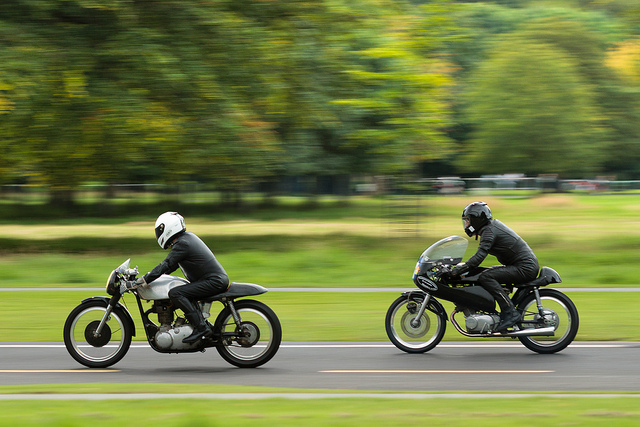Can you tell me more about the motorcycles they're riding? The motorcycles are styled after vintage or cafe racer bikes, known for their retro design and minimalist appearance. These types of motorcycles emphasize speed and handling rather than comfort, embracing a classic motorcycling aesthetic. 